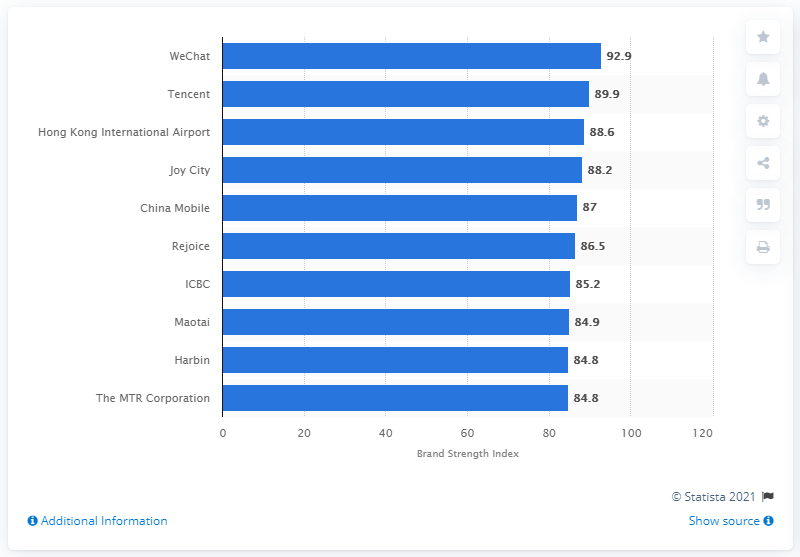Highlight a few significant elements in this photo. According to the average index of the top three brands, the value is approximately 90.5. WeChat is the number one brand in the chart. According to the Brand Strength Index in 2020, the top ten strongest Chinese brands are: In 2020, WeChat's Brand Strength Index score was 92.9, indicating strong brand recognition and positive brand perception among its target audience. 